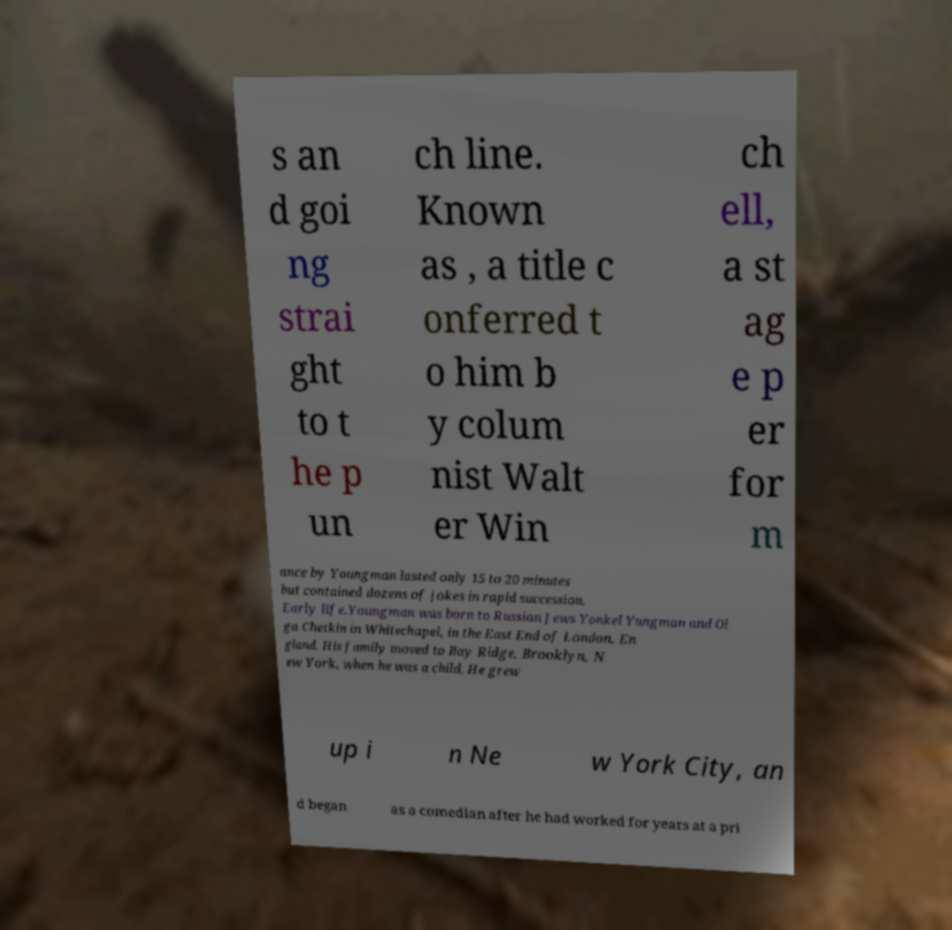What messages or text are displayed in this image? I need them in a readable, typed format. s an d goi ng strai ght to t he p un ch line. Known as , a title c onferred t o him b y colum nist Walt er Win ch ell, a st ag e p er for m ance by Youngman lasted only 15 to 20 minutes but contained dozens of jokes in rapid succession. Early life.Youngman was born to Russian Jews Yonkel Yungman and Ol ga Chetkin in Whitechapel, in the East End of London, En gland. His family moved to Bay Ridge, Brooklyn, N ew York, when he was a child. He grew up i n Ne w York City, an d began as a comedian after he had worked for years at a pri 